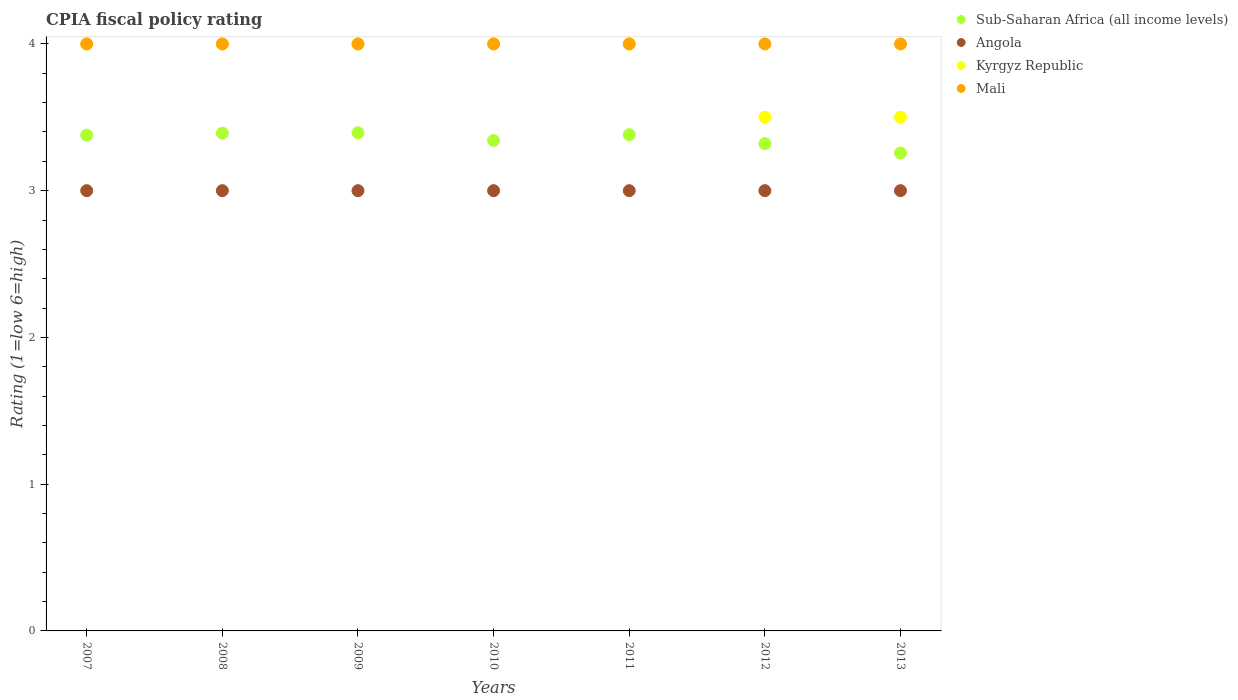Is the number of dotlines equal to the number of legend labels?
Offer a very short reply. Yes. What is the CPIA rating in Kyrgyz Republic in 2010?
Make the answer very short. 4. In which year was the CPIA rating in Kyrgyz Republic minimum?
Your answer should be compact. 2012. What is the total CPIA rating in Sub-Saharan Africa (all income levels) in the graph?
Make the answer very short. 23.47. What is the difference between the CPIA rating in Mali in 2012 and the CPIA rating in Sub-Saharan Africa (all income levels) in 2007?
Offer a terse response. 0.62. What is the average CPIA rating in Kyrgyz Republic per year?
Offer a very short reply. 3.86. In the year 2009, what is the difference between the CPIA rating in Sub-Saharan Africa (all income levels) and CPIA rating in Angola?
Keep it short and to the point. 0.39. Is the difference between the CPIA rating in Sub-Saharan Africa (all income levels) in 2007 and 2012 greater than the difference between the CPIA rating in Angola in 2007 and 2012?
Offer a terse response. Yes. What is the difference between the highest and the second highest CPIA rating in Sub-Saharan Africa (all income levels)?
Keep it short and to the point. 0. What is the difference between the highest and the lowest CPIA rating in Kyrgyz Republic?
Provide a short and direct response. 0.5. Is the sum of the CPIA rating in Kyrgyz Republic in 2008 and 2012 greater than the maximum CPIA rating in Mali across all years?
Provide a short and direct response. Yes. Is it the case that in every year, the sum of the CPIA rating in Angola and CPIA rating in Kyrgyz Republic  is greater than the CPIA rating in Sub-Saharan Africa (all income levels)?
Offer a terse response. Yes. Is the CPIA rating in Kyrgyz Republic strictly greater than the CPIA rating in Mali over the years?
Provide a short and direct response. No. How many years are there in the graph?
Make the answer very short. 7. What is the difference between two consecutive major ticks on the Y-axis?
Ensure brevity in your answer.  1. Are the values on the major ticks of Y-axis written in scientific E-notation?
Your answer should be compact. No. Does the graph contain grids?
Your response must be concise. No. Where does the legend appear in the graph?
Offer a terse response. Top right. How are the legend labels stacked?
Offer a very short reply. Vertical. What is the title of the graph?
Make the answer very short. CPIA fiscal policy rating. Does "Botswana" appear as one of the legend labels in the graph?
Keep it short and to the point. No. What is the Rating (1=low 6=high) in Sub-Saharan Africa (all income levels) in 2007?
Provide a short and direct response. 3.38. What is the Rating (1=low 6=high) in Sub-Saharan Africa (all income levels) in 2008?
Give a very brief answer. 3.39. What is the Rating (1=low 6=high) in Mali in 2008?
Make the answer very short. 4. What is the Rating (1=low 6=high) in Sub-Saharan Africa (all income levels) in 2009?
Ensure brevity in your answer.  3.39. What is the Rating (1=low 6=high) in Angola in 2009?
Offer a terse response. 3. What is the Rating (1=low 6=high) in Mali in 2009?
Your answer should be compact. 4. What is the Rating (1=low 6=high) of Sub-Saharan Africa (all income levels) in 2010?
Your answer should be compact. 3.34. What is the Rating (1=low 6=high) in Angola in 2010?
Offer a very short reply. 3. What is the Rating (1=low 6=high) of Kyrgyz Republic in 2010?
Offer a very short reply. 4. What is the Rating (1=low 6=high) of Sub-Saharan Africa (all income levels) in 2011?
Your answer should be compact. 3.38. What is the Rating (1=low 6=high) in Mali in 2011?
Your answer should be compact. 4. What is the Rating (1=low 6=high) of Sub-Saharan Africa (all income levels) in 2012?
Offer a very short reply. 3.32. What is the Rating (1=low 6=high) in Sub-Saharan Africa (all income levels) in 2013?
Your answer should be very brief. 3.26. What is the Rating (1=low 6=high) of Angola in 2013?
Your response must be concise. 3. What is the Rating (1=low 6=high) in Kyrgyz Republic in 2013?
Provide a succinct answer. 3.5. What is the Rating (1=low 6=high) of Mali in 2013?
Keep it short and to the point. 4. Across all years, what is the maximum Rating (1=low 6=high) of Sub-Saharan Africa (all income levels)?
Your answer should be compact. 3.39. Across all years, what is the maximum Rating (1=low 6=high) of Angola?
Provide a short and direct response. 3. Across all years, what is the maximum Rating (1=low 6=high) of Mali?
Keep it short and to the point. 4. Across all years, what is the minimum Rating (1=low 6=high) in Sub-Saharan Africa (all income levels)?
Provide a short and direct response. 3.26. Across all years, what is the minimum Rating (1=low 6=high) of Angola?
Keep it short and to the point. 3. Across all years, what is the minimum Rating (1=low 6=high) in Kyrgyz Republic?
Your answer should be compact. 3.5. What is the total Rating (1=low 6=high) of Sub-Saharan Africa (all income levels) in the graph?
Ensure brevity in your answer.  23.47. What is the difference between the Rating (1=low 6=high) of Sub-Saharan Africa (all income levels) in 2007 and that in 2008?
Your answer should be very brief. -0.01. What is the difference between the Rating (1=low 6=high) in Angola in 2007 and that in 2008?
Your answer should be compact. 0. What is the difference between the Rating (1=low 6=high) in Sub-Saharan Africa (all income levels) in 2007 and that in 2009?
Your answer should be very brief. -0.02. What is the difference between the Rating (1=low 6=high) in Sub-Saharan Africa (all income levels) in 2007 and that in 2010?
Your response must be concise. 0.04. What is the difference between the Rating (1=low 6=high) in Angola in 2007 and that in 2010?
Provide a short and direct response. 0. What is the difference between the Rating (1=low 6=high) of Mali in 2007 and that in 2010?
Ensure brevity in your answer.  0. What is the difference between the Rating (1=low 6=high) of Sub-Saharan Africa (all income levels) in 2007 and that in 2011?
Provide a succinct answer. -0. What is the difference between the Rating (1=low 6=high) in Angola in 2007 and that in 2011?
Provide a succinct answer. 0. What is the difference between the Rating (1=low 6=high) in Kyrgyz Republic in 2007 and that in 2011?
Offer a very short reply. 0. What is the difference between the Rating (1=low 6=high) in Sub-Saharan Africa (all income levels) in 2007 and that in 2012?
Your answer should be compact. 0.06. What is the difference between the Rating (1=low 6=high) in Angola in 2007 and that in 2012?
Ensure brevity in your answer.  0. What is the difference between the Rating (1=low 6=high) in Mali in 2007 and that in 2012?
Offer a terse response. 0. What is the difference between the Rating (1=low 6=high) in Sub-Saharan Africa (all income levels) in 2007 and that in 2013?
Provide a short and direct response. 0.12. What is the difference between the Rating (1=low 6=high) of Kyrgyz Republic in 2007 and that in 2013?
Make the answer very short. 0.5. What is the difference between the Rating (1=low 6=high) of Sub-Saharan Africa (all income levels) in 2008 and that in 2009?
Offer a very short reply. -0. What is the difference between the Rating (1=low 6=high) in Sub-Saharan Africa (all income levels) in 2008 and that in 2010?
Provide a succinct answer. 0.05. What is the difference between the Rating (1=low 6=high) in Mali in 2008 and that in 2010?
Offer a terse response. 0. What is the difference between the Rating (1=low 6=high) in Sub-Saharan Africa (all income levels) in 2008 and that in 2011?
Provide a short and direct response. 0.01. What is the difference between the Rating (1=low 6=high) of Angola in 2008 and that in 2011?
Offer a very short reply. 0. What is the difference between the Rating (1=low 6=high) in Kyrgyz Republic in 2008 and that in 2011?
Provide a succinct answer. 0. What is the difference between the Rating (1=low 6=high) in Sub-Saharan Africa (all income levels) in 2008 and that in 2012?
Make the answer very short. 0.07. What is the difference between the Rating (1=low 6=high) in Angola in 2008 and that in 2012?
Offer a very short reply. 0. What is the difference between the Rating (1=low 6=high) in Sub-Saharan Africa (all income levels) in 2008 and that in 2013?
Your answer should be compact. 0.14. What is the difference between the Rating (1=low 6=high) of Angola in 2008 and that in 2013?
Make the answer very short. 0. What is the difference between the Rating (1=low 6=high) in Kyrgyz Republic in 2008 and that in 2013?
Offer a very short reply. 0.5. What is the difference between the Rating (1=low 6=high) in Sub-Saharan Africa (all income levels) in 2009 and that in 2010?
Give a very brief answer. 0.05. What is the difference between the Rating (1=low 6=high) of Sub-Saharan Africa (all income levels) in 2009 and that in 2011?
Make the answer very short. 0.01. What is the difference between the Rating (1=low 6=high) of Angola in 2009 and that in 2011?
Offer a very short reply. 0. What is the difference between the Rating (1=low 6=high) of Sub-Saharan Africa (all income levels) in 2009 and that in 2012?
Ensure brevity in your answer.  0.07. What is the difference between the Rating (1=low 6=high) in Angola in 2009 and that in 2012?
Your answer should be very brief. 0. What is the difference between the Rating (1=low 6=high) of Sub-Saharan Africa (all income levels) in 2009 and that in 2013?
Make the answer very short. 0.14. What is the difference between the Rating (1=low 6=high) of Angola in 2009 and that in 2013?
Offer a terse response. 0. What is the difference between the Rating (1=low 6=high) in Mali in 2009 and that in 2013?
Offer a terse response. 0. What is the difference between the Rating (1=low 6=high) of Sub-Saharan Africa (all income levels) in 2010 and that in 2011?
Keep it short and to the point. -0.04. What is the difference between the Rating (1=low 6=high) of Sub-Saharan Africa (all income levels) in 2010 and that in 2012?
Ensure brevity in your answer.  0.02. What is the difference between the Rating (1=low 6=high) in Angola in 2010 and that in 2012?
Your response must be concise. 0. What is the difference between the Rating (1=low 6=high) in Mali in 2010 and that in 2012?
Your answer should be very brief. 0. What is the difference between the Rating (1=low 6=high) in Sub-Saharan Africa (all income levels) in 2010 and that in 2013?
Your answer should be compact. 0.09. What is the difference between the Rating (1=low 6=high) of Kyrgyz Republic in 2010 and that in 2013?
Give a very brief answer. 0.5. What is the difference between the Rating (1=low 6=high) in Sub-Saharan Africa (all income levels) in 2011 and that in 2012?
Keep it short and to the point. 0.06. What is the difference between the Rating (1=low 6=high) of Kyrgyz Republic in 2011 and that in 2012?
Provide a succinct answer. 0.5. What is the difference between the Rating (1=low 6=high) of Mali in 2011 and that in 2012?
Provide a short and direct response. 0. What is the difference between the Rating (1=low 6=high) in Sub-Saharan Africa (all income levels) in 2011 and that in 2013?
Your answer should be very brief. 0.13. What is the difference between the Rating (1=low 6=high) in Sub-Saharan Africa (all income levels) in 2012 and that in 2013?
Offer a terse response. 0.06. What is the difference between the Rating (1=low 6=high) in Angola in 2012 and that in 2013?
Keep it short and to the point. 0. What is the difference between the Rating (1=low 6=high) in Mali in 2012 and that in 2013?
Offer a very short reply. 0. What is the difference between the Rating (1=low 6=high) in Sub-Saharan Africa (all income levels) in 2007 and the Rating (1=low 6=high) in Angola in 2008?
Your answer should be very brief. 0.38. What is the difference between the Rating (1=low 6=high) of Sub-Saharan Africa (all income levels) in 2007 and the Rating (1=low 6=high) of Kyrgyz Republic in 2008?
Ensure brevity in your answer.  -0.62. What is the difference between the Rating (1=low 6=high) in Sub-Saharan Africa (all income levels) in 2007 and the Rating (1=low 6=high) in Mali in 2008?
Your response must be concise. -0.62. What is the difference between the Rating (1=low 6=high) in Sub-Saharan Africa (all income levels) in 2007 and the Rating (1=low 6=high) in Angola in 2009?
Keep it short and to the point. 0.38. What is the difference between the Rating (1=low 6=high) of Sub-Saharan Africa (all income levels) in 2007 and the Rating (1=low 6=high) of Kyrgyz Republic in 2009?
Your response must be concise. -0.62. What is the difference between the Rating (1=low 6=high) in Sub-Saharan Africa (all income levels) in 2007 and the Rating (1=low 6=high) in Mali in 2009?
Provide a succinct answer. -0.62. What is the difference between the Rating (1=low 6=high) of Angola in 2007 and the Rating (1=low 6=high) of Kyrgyz Republic in 2009?
Offer a very short reply. -1. What is the difference between the Rating (1=low 6=high) in Angola in 2007 and the Rating (1=low 6=high) in Mali in 2009?
Provide a short and direct response. -1. What is the difference between the Rating (1=low 6=high) of Kyrgyz Republic in 2007 and the Rating (1=low 6=high) of Mali in 2009?
Provide a short and direct response. 0. What is the difference between the Rating (1=low 6=high) in Sub-Saharan Africa (all income levels) in 2007 and the Rating (1=low 6=high) in Angola in 2010?
Make the answer very short. 0.38. What is the difference between the Rating (1=low 6=high) of Sub-Saharan Africa (all income levels) in 2007 and the Rating (1=low 6=high) of Kyrgyz Republic in 2010?
Offer a terse response. -0.62. What is the difference between the Rating (1=low 6=high) of Sub-Saharan Africa (all income levels) in 2007 and the Rating (1=low 6=high) of Mali in 2010?
Your answer should be very brief. -0.62. What is the difference between the Rating (1=low 6=high) of Angola in 2007 and the Rating (1=low 6=high) of Mali in 2010?
Ensure brevity in your answer.  -1. What is the difference between the Rating (1=low 6=high) in Sub-Saharan Africa (all income levels) in 2007 and the Rating (1=low 6=high) in Angola in 2011?
Offer a terse response. 0.38. What is the difference between the Rating (1=low 6=high) of Sub-Saharan Africa (all income levels) in 2007 and the Rating (1=low 6=high) of Kyrgyz Republic in 2011?
Give a very brief answer. -0.62. What is the difference between the Rating (1=low 6=high) in Sub-Saharan Africa (all income levels) in 2007 and the Rating (1=low 6=high) in Mali in 2011?
Provide a succinct answer. -0.62. What is the difference between the Rating (1=low 6=high) in Sub-Saharan Africa (all income levels) in 2007 and the Rating (1=low 6=high) in Angola in 2012?
Ensure brevity in your answer.  0.38. What is the difference between the Rating (1=low 6=high) in Sub-Saharan Africa (all income levels) in 2007 and the Rating (1=low 6=high) in Kyrgyz Republic in 2012?
Ensure brevity in your answer.  -0.12. What is the difference between the Rating (1=low 6=high) in Sub-Saharan Africa (all income levels) in 2007 and the Rating (1=low 6=high) in Mali in 2012?
Make the answer very short. -0.62. What is the difference between the Rating (1=low 6=high) in Angola in 2007 and the Rating (1=low 6=high) in Mali in 2012?
Provide a succinct answer. -1. What is the difference between the Rating (1=low 6=high) of Kyrgyz Republic in 2007 and the Rating (1=low 6=high) of Mali in 2012?
Ensure brevity in your answer.  0. What is the difference between the Rating (1=low 6=high) of Sub-Saharan Africa (all income levels) in 2007 and the Rating (1=low 6=high) of Angola in 2013?
Your answer should be very brief. 0.38. What is the difference between the Rating (1=low 6=high) in Sub-Saharan Africa (all income levels) in 2007 and the Rating (1=low 6=high) in Kyrgyz Republic in 2013?
Offer a very short reply. -0.12. What is the difference between the Rating (1=low 6=high) of Sub-Saharan Africa (all income levels) in 2007 and the Rating (1=low 6=high) of Mali in 2013?
Give a very brief answer. -0.62. What is the difference between the Rating (1=low 6=high) in Angola in 2007 and the Rating (1=low 6=high) in Kyrgyz Republic in 2013?
Your answer should be very brief. -0.5. What is the difference between the Rating (1=low 6=high) in Sub-Saharan Africa (all income levels) in 2008 and the Rating (1=low 6=high) in Angola in 2009?
Provide a short and direct response. 0.39. What is the difference between the Rating (1=low 6=high) in Sub-Saharan Africa (all income levels) in 2008 and the Rating (1=low 6=high) in Kyrgyz Republic in 2009?
Your answer should be compact. -0.61. What is the difference between the Rating (1=low 6=high) in Sub-Saharan Africa (all income levels) in 2008 and the Rating (1=low 6=high) in Mali in 2009?
Give a very brief answer. -0.61. What is the difference between the Rating (1=low 6=high) of Angola in 2008 and the Rating (1=low 6=high) of Kyrgyz Republic in 2009?
Your answer should be very brief. -1. What is the difference between the Rating (1=low 6=high) of Angola in 2008 and the Rating (1=low 6=high) of Mali in 2009?
Provide a succinct answer. -1. What is the difference between the Rating (1=low 6=high) in Kyrgyz Republic in 2008 and the Rating (1=low 6=high) in Mali in 2009?
Ensure brevity in your answer.  0. What is the difference between the Rating (1=low 6=high) in Sub-Saharan Africa (all income levels) in 2008 and the Rating (1=low 6=high) in Angola in 2010?
Your response must be concise. 0.39. What is the difference between the Rating (1=low 6=high) of Sub-Saharan Africa (all income levels) in 2008 and the Rating (1=low 6=high) of Kyrgyz Republic in 2010?
Ensure brevity in your answer.  -0.61. What is the difference between the Rating (1=low 6=high) of Sub-Saharan Africa (all income levels) in 2008 and the Rating (1=low 6=high) of Mali in 2010?
Your answer should be very brief. -0.61. What is the difference between the Rating (1=low 6=high) of Angola in 2008 and the Rating (1=low 6=high) of Kyrgyz Republic in 2010?
Give a very brief answer. -1. What is the difference between the Rating (1=low 6=high) of Angola in 2008 and the Rating (1=low 6=high) of Mali in 2010?
Make the answer very short. -1. What is the difference between the Rating (1=low 6=high) of Kyrgyz Republic in 2008 and the Rating (1=low 6=high) of Mali in 2010?
Keep it short and to the point. 0. What is the difference between the Rating (1=low 6=high) of Sub-Saharan Africa (all income levels) in 2008 and the Rating (1=low 6=high) of Angola in 2011?
Keep it short and to the point. 0.39. What is the difference between the Rating (1=low 6=high) of Sub-Saharan Africa (all income levels) in 2008 and the Rating (1=low 6=high) of Kyrgyz Republic in 2011?
Give a very brief answer. -0.61. What is the difference between the Rating (1=low 6=high) in Sub-Saharan Africa (all income levels) in 2008 and the Rating (1=low 6=high) in Mali in 2011?
Make the answer very short. -0.61. What is the difference between the Rating (1=low 6=high) in Angola in 2008 and the Rating (1=low 6=high) in Kyrgyz Republic in 2011?
Make the answer very short. -1. What is the difference between the Rating (1=low 6=high) in Angola in 2008 and the Rating (1=low 6=high) in Mali in 2011?
Offer a terse response. -1. What is the difference between the Rating (1=low 6=high) of Kyrgyz Republic in 2008 and the Rating (1=low 6=high) of Mali in 2011?
Provide a short and direct response. 0. What is the difference between the Rating (1=low 6=high) of Sub-Saharan Africa (all income levels) in 2008 and the Rating (1=low 6=high) of Angola in 2012?
Your answer should be very brief. 0.39. What is the difference between the Rating (1=low 6=high) in Sub-Saharan Africa (all income levels) in 2008 and the Rating (1=low 6=high) in Kyrgyz Republic in 2012?
Give a very brief answer. -0.11. What is the difference between the Rating (1=low 6=high) of Sub-Saharan Africa (all income levels) in 2008 and the Rating (1=low 6=high) of Mali in 2012?
Offer a terse response. -0.61. What is the difference between the Rating (1=low 6=high) in Angola in 2008 and the Rating (1=low 6=high) in Mali in 2012?
Provide a short and direct response. -1. What is the difference between the Rating (1=low 6=high) in Kyrgyz Republic in 2008 and the Rating (1=low 6=high) in Mali in 2012?
Keep it short and to the point. 0. What is the difference between the Rating (1=low 6=high) of Sub-Saharan Africa (all income levels) in 2008 and the Rating (1=low 6=high) of Angola in 2013?
Provide a short and direct response. 0.39. What is the difference between the Rating (1=low 6=high) in Sub-Saharan Africa (all income levels) in 2008 and the Rating (1=low 6=high) in Kyrgyz Republic in 2013?
Provide a short and direct response. -0.11. What is the difference between the Rating (1=low 6=high) in Sub-Saharan Africa (all income levels) in 2008 and the Rating (1=low 6=high) in Mali in 2013?
Provide a short and direct response. -0.61. What is the difference between the Rating (1=low 6=high) in Angola in 2008 and the Rating (1=low 6=high) in Kyrgyz Republic in 2013?
Provide a short and direct response. -0.5. What is the difference between the Rating (1=low 6=high) in Angola in 2008 and the Rating (1=low 6=high) in Mali in 2013?
Offer a very short reply. -1. What is the difference between the Rating (1=low 6=high) of Kyrgyz Republic in 2008 and the Rating (1=low 6=high) of Mali in 2013?
Provide a succinct answer. 0. What is the difference between the Rating (1=low 6=high) in Sub-Saharan Africa (all income levels) in 2009 and the Rating (1=low 6=high) in Angola in 2010?
Keep it short and to the point. 0.39. What is the difference between the Rating (1=low 6=high) in Sub-Saharan Africa (all income levels) in 2009 and the Rating (1=low 6=high) in Kyrgyz Republic in 2010?
Give a very brief answer. -0.61. What is the difference between the Rating (1=low 6=high) in Sub-Saharan Africa (all income levels) in 2009 and the Rating (1=low 6=high) in Mali in 2010?
Ensure brevity in your answer.  -0.61. What is the difference between the Rating (1=low 6=high) in Angola in 2009 and the Rating (1=low 6=high) in Kyrgyz Republic in 2010?
Provide a succinct answer. -1. What is the difference between the Rating (1=low 6=high) of Angola in 2009 and the Rating (1=low 6=high) of Mali in 2010?
Your answer should be compact. -1. What is the difference between the Rating (1=low 6=high) of Sub-Saharan Africa (all income levels) in 2009 and the Rating (1=low 6=high) of Angola in 2011?
Keep it short and to the point. 0.39. What is the difference between the Rating (1=low 6=high) of Sub-Saharan Africa (all income levels) in 2009 and the Rating (1=low 6=high) of Kyrgyz Republic in 2011?
Offer a very short reply. -0.61. What is the difference between the Rating (1=low 6=high) of Sub-Saharan Africa (all income levels) in 2009 and the Rating (1=low 6=high) of Mali in 2011?
Make the answer very short. -0.61. What is the difference between the Rating (1=low 6=high) of Angola in 2009 and the Rating (1=low 6=high) of Kyrgyz Republic in 2011?
Your answer should be compact. -1. What is the difference between the Rating (1=low 6=high) in Angola in 2009 and the Rating (1=low 6=high) in Mali in 2011?
Make the answer very short. -1. What is the difference between the Rating (1=low 6=high) of Kyrgyz Republic in 2009 and the Rating (1=low 6=high) of Mali in 2011?
Your answer should be compact. 0. What is the difference between the Rating (1=low 6=high) of Sub-Saharan Africa (all income levels) in 2009 and the Rating (1=low 6=high) of Angola in 2012?
Offer a terse response. 0.39. What is the difference between the Rating (1=low 6=high) in Sub-Saharan Africa (all income levels) in 2009 and the Rating (1=low 6=high) in Kyrgyz Republic in 2012?
Keep it short and to the point. -0.11. What is the difference between the Rating (1=low 6=high) in Sub-Saharan Africa (all income levels) in 2009 and the Rating (1=low 6=high) in Mali in 2012?
Provide a succinct answer. -0.61. What is the difference between the Rating (1=low 6=high) in Sub-Saharan Africa (all income levels) in 2009 and the Rating (1=low 6=high) in Angola in 2013?
Provide a short and direct response. 0.39. What is the difference between the Rating (1=low 6=high) of Sub-Saharan Africa (all income levels) in 2009 and the Rating (1=low 6=high) of Kyrgyz Republic in 2013?
Offer a terse response. -0.11. What is the difference between the Rating (1=low 6=high) of Sub-Saharan Africa (all income levels) in 2009 and the Rating (1=low 6=high) of Mali in 2013?
Your response must be concise. -0.61. What is the difference between the Rating (1=low 6=high) of Angola in 2009 and the Rating (1=low 6=high) of Kyrgyz Republic in 2013?
Keep it short and to the point. -0.5. What is the difference between the Rating (1=low 6=high) in Sub-Saharan Africa (all income levels) in 2010 and the Rating (1=low 6=high) in Angola in 2011?
Your answer should be compact. 0.34. What is the difference between the Rating (1=low 6=high) of Sub-Saharan Africa (all income levels) in 2010 and the Rating (1=low 6=high) of Kyrgyz Republic in 2011?
Give a very brief answer. -0.66. What is the difference between the Rating (1=low 6=high) of Sub-Saharan Africa (all income levels) in 2010 and the Rating (1=low 6=high) of Mali in 2011?
Offer a very short reply. -0.66. What is the difference between the Rating (1=low 6=high) of Angola in 2010 and the Rating (1=low 6=high) of Kyrgyz Republic in 2011?
Offer a very short reply. -1. What is the difference between the Rating (1=low 6=high) in Sub-Saharan Africa (all income levels) in 2010 and the Rating (1=low 6=high) in Angola in 2012?
Your answer should be compact. 0.34. What is the difference between the Rating (1=low 6=high) of Sub-Saharan Africa (all income levels) in 2010 and the Rating (1=low 6=high) of Kyrgyz Republic in 2012?
Provide a succinct answer. -0.16. What is the difference between the Rating (1=low 6=high) of Sub-Saharan Africa (all income levels) in 2010 and the Rating (1=low 6=high) of Mali in 2012?
Offer a very short reply. -0.66. What is the difference between the Rating (1=low 6=high) of Angola in 2010 and the Rating (1=low 6=high) of Mali in 2012?
Offer a terse response. -1. What is the difference between the Rating (1=low 6=high) in Kyrgyz Republic in 2010 and the Rating (1=low 6=high) in Mali in 2012?
Ensure brevity in your answer.  0. What is the difference between the Rating (1=low 6=high) in Sub-Saharan Africa (all income levels) in 2010 and the Rating (1=low 6=high) in Angola in 2013?
Keep it short and to the point. 0.34. What is the difference between the Rating (1=low 6=high) in Sub-Saharan Africa (all income levels) in 2010 and the Rating (1=low 6=high) in Kyrgyz Republic in 2013?
Your response must be concise. -0.16. What is the difference between the Rating (1=low 6=high) in Sub-Saharan Africa (all income levels) in 2010 and the Rating (1=low 6=high) in Mali in 2013?
Provide a succinct answer. -0.66. What is the difference between the Rating (1=low 6=high) of Sub-Saharan Africa (all income levels) in 2011 and the Rating (1=low 6=high) of Angola in 2012?
Provide a short and direct response. 0.38. What is the difference between the Rating (1=low 6=high) of Sub-Saharan Africa (all income levels) in 2011 and the Rating (1=low 6=high) of Kyrgyz Republic in 2012?
Give a very brief answer. -0.12. What is the difference between the Rating (1=low 6=high) of Sub-Saharan Africa (all income levels) in 2011 and the Rating (1=low 6=high) of Mali in 2012?
Make the answer very short. -0.62. What is the difference between the Rating (1=low 6=high) of Kyrgyz Republic in 2011 and the Rating (1=low 6=high) of Mali in 2012?
Provide a succinct answer. 0. What is the difference between the Rating (1=low 6=high) of Sub-Saharan Africa (all income levels) in 2011 and the Rating (1=low 6=high) of Angola in 2013?
Ensure brevity in your answer.  0.38. What is the difference between the Rating (1=low 6=high) in Sub-Saharan Africa (all income levels) in 2011 and the Rating (1=low 6=high) in Kyrgyz Republic in 2013?
Offer a very short reply. -0.12. What is the difference between the Rating (1=low 6=high) of Sub-Saharan Africa (all income levels) in 2011 and the Rating (1=low 6=high) of Mali in 2013?
Offer a terse response. -0.62. What is the difference between the Rating (1=low 6=high) in Angola in 2011 and the Rating (1=low 6=high) in Mali in 2013?
Ensure brevity in your answer.  -1. What is the difference between the Rating (1=low 6=high) of Kyrgyz Republic in 2011 and the Rating (1=low 6=high) of Mali in 2013?
Provide a short and direct response. 0. What is the difference between the Rating (1=low 6=high) of Sub-Saharan Africa (all income levels) in 2012 and the Rating (1=low 6=high) of Angola in 2013?
Keep it short and to the point. 0.32. What is the difference between the Rating (1=low 6=high) in Sub-Saharan Africa (all income levels) in 2012 and the Rating (1=low 6=high) in Kyrgyz Republic in 2013?
Your answer should be very brief. -0.18. What is the difference between the Rating (1=low 6=high) in Sub-Saharan Africa (all income levels) in 2012 and the Rating (1=low 6=high) in Mali in 2013?
Ensure brevity in your answer.  -0.68. What is the difference between the Rating (1=low 6=high) in Angola in 2012 and the Rating (1=low 6=high) in Kyrgyz Republic in 2013?
Your answer should be compact. -0.5. What is the difference between the Rating (1=low 6=high) of Kyrgyz Republic in 2012 and the Rating (1=low 6=high) of Mali in 2013?
Provide a succinct answer. -0.5. What is the average Rating (1=low 6=high) of Sub-Saharan Africa (all income levels) per year?
Provide a short and direct response. 3.35. What is the average Rating (1=low 6=high) in Angola per year?
Offer a very short reply. 3. What is the average Rating (1=low 6=high) in Kyrgyz Republic per year?
Keep it short and to the point. 3.86. In the year 2007, what is the difference between the Rating (1=low 6=high) of Sub-Saharan Africa (all income levels) and Rating (1=low 6=high) of Angola?
Give a very brief answer. 0.38. In the year 2007, what is the difference between the Rating (1=low 6=high) of Sub-Saharan Africa (all income levels) and Rating (1=low 6=high) of Kyrgyz Republic?
Ensure brevity in your answer.  -0.62. In the year 2007, what is the difference between the Rating (1=low 6=high) in Sub-Saharan Africa (all income levels) and Rating (1=low 6=high) in Mali?
Your answer should be very brief. -0.62. In the year 2007, what is the difference between the Rating (1=low 6=high) in Angola and Rating (1=low 6=high) in Kyrgyz Republic?
Make the answer very short. -1. In the year 2008, what is the difference between the Rating (1=low 6=high) of Sub-Saharan Africa (all income levels) and Rating (1=low 6=high) of Angola?
Provide a short and direct response. 0.39. In the year 2008, what is the difference between the Rating (1=low 6=high) of Sub-Saharan Africa (all income levels) and Rating (1=low 6=high) of Kyrgyz Republic?
Give a very brief answer. -0.61. In the year 2008, what is the difference between the Rating (1=low 6=high) of Sub-Saharan Africa (all income levels) and Rating (1=low 6=high) of Mali?
Your response must be concise. -0.61. In the year 2008, what is the difference between the Rating (1=low 6=high) in Angola and Rating (1=low 6=high) in Mali?
Offer a terse response. -1. In the year 2009, what is the difference between the Rating (1=low 6=high) in Sub-Saharan Africa (all income levels) and Rating (1=low 6=high) in Angola?
Offer a terse response. 0.39. In the year 2009, what is the difference between the Rating (1=low 6=high) in Sub-Saharan Africa (all income levels) and Rating (1=low 6=high) in Kyrgyz Republic?
Provide a succinct answer. -0.61. In the year 2009, what is the difference between the Rating (1=low 6=high) of Sub-Saharan Africa (all income levels) and Rating (1=low 6=high) of Mali?
Offer a very short reply. -0.61. In the year 2009, what is the difference between the Rating (1=low 6=high) in Angola and Rating (1=low 6=high) in Kyrgyz Republic?
Your answer should be compact. -1. In the year 2009, what is the difference between the Rating (1=low 6=high) of Angola and Rating (1=low 6=high) of Mali?
Offer a terse response. -1. In the year 2010, what is the difference between the Rating (1=low 6=high) in Sub-Saharan Africa (all income levels) and Rating (1=low 6=high) in Angola?
Offer a very short reply. 0.34. In the year 2010, what is the difference between the Rating (1=low 6=high) of Sub-Saharan Africa (all income levels) and Rating (1=low 6=high) of Kyrgyz Republic?
Offer a terse response. -0.66. In the year 2010, what is the difference between the Rating (1=low 6=high) in Sub-Saharan Africa (all income levels) and Rating (1=low 6=high) in Mali?
Give a very brief answer. -0.66. In the year 2010, what is the difference between the Rating (1=low 6=high) in Angola and Rating (1=low 6=high) in Kyrgyz Republic?
Give a very brief answer. -1. In the year 2010, what is the difference between the Rating (1=low 6=high) in Angola and Rating (1=low 6=high) in Mali?
Your answer should be very brief. -1. In the year 2010, what is the difference between the Rating (1=low 6=high) in Kyrgyz Republic and Rating (1=low 6=high) in Mali?
Offer a terse response. 0. In the year 2011, what is the difference between the Rating (1=low 6=high) in Sub-Saharan Africa (all income levels) and Rating (1=low 6=high) in Angola?
Offer a terse response. 0.38. In the year 2011, what is the difference between the Rating (1=low 6=high) of Sub-Saharan Africa (all income levels) and Rating (1=low 6=high) of Kyrgyz Republic?
Your answer should be compact. -0.62. In the year 2011, what is the difference between the Rating (1=low 6=high) in Sub-Saharan Africa (all income levels) and Rating (1=low 6=high) in Mali?
Offer a terse response. -0.62. In the year 2011, what is the difference between the Rating (1=low 6=high) of Angola and Rating (1=low 6=high) of Kyrgyz Republic?
Your answer should be very brief. -1. In the year 2011, what is the difference between the Rating (1=low 6=high) in Angola and Rating (1=low 6=high) in Mali?
Keep it short and to the point. -1. In the year 2012, what is the difference between the Rating (1=low 6=high) in Sub-Saharan Africa (all income levels) and Rating (1=low 6=high) in Angola?
Offer a very short reply. 0.32. In the year 2012, what is the difference between the Rating (1=low 6=high) in Sub-Saharan Africa (all income levels) and Rating (1=low 6=high) in Kyrgyz Republic?
Your response must be concise. -0.18. In the year 2012, what is the difference between the Rating (1=low 6=high) in Sub-Saharan Africa (all income levels) and Rating (1=low 6=high) in Mali?
Your answer should be very brief. -0.68. In the year 2013, what is the difference between the Rating (1=low 6=high) in Sub-Saharan Africa (all income levels) and Rating (1=low 6=high) in Angola?
Provide a short and direct response. 0.26. In the year 2013, what is the difference between the Rating (1=low 6=high) in Sub-Saharan Africa (all income levels) and Rating (1=low 6=high) in Kyrgyz Republic?
Your answer should be compact. -0.24. In the year 2013, what is the difference between the Rating (1=low 6=high) in Sub-Saharan Africa (all income levels) and Rating (1=low 6=high) in Mali?
Your response must be concise. -0.74. In the year 2013, what is the difference between the Rating (1=low 6=high) of Angola and Rating (1=low 6=high) of Mali?
Your response must be concise. -1. In the year 2013, what is the difference between the Rating (1=low 6=high) of Kyrgyz Republic and Rating (1=low 6=high) of Mali?
Offer a very short reply. -0.5. What is the ratio of the Rating (1=low 6=high) of Angola in 2007 to that in 2008?
Provide a succinct answer. 1. What is the ratio of the Rating (1=low 6=high) of Kyrgyz Republic in 2007 to that in 2008?
Give a very brief answer. 1. What is the ratio of the Rating (1=low 6=high) in Sub-Saharan Africa (all income levels) in 2007 to that in 2009?
Offer a very short reply. 1. What is the ratio of the Rating (1=low 6=high) in Sub-Saharan Africa (all income levels) in 2007 to that in 2010?
Make the answer very short. 1.01. What is the ratio of the Rating (1=low 6=high) of Mali in 2007 to that in 2010?
Make the answer very short. 1. What is the ratio of the Rating (1=low 6=high) in Sub-Saharan Africa (all income levels) in 2007 to that in 2011?
Your answer should be compact. 1. What is the ratio of the Rating (1=low 6=high) of Kyrgyz Republic in 2007 to that in 2011?
Your response must be concise. 1. What is the ratio of the Rating (1=low 6=high) in Sub-Saharan Africa (all income levels) in 2007 to that in 2012?
Keep it short and to the point. 1.02. What is the ratio of the Rating (1=low 6=high) of Angola in 2007 to that in 2012?
Make the answer very short. 1. What is the ratio of the Rating (1=low 6=high) in Mali in 2007 to that in 2012?
Keep it short and to the point. 1. What is the ratio of the Rating (1=low 6=high) in Sub-Saharan Africa (all income levels) in 2007 to that in 2013?
Offer a very short reply. 1.04. What is the ratio of the Rating (1=low 6=high) of Angola in 2007 to that in 2013?
Provide a succinct answer. 1. What is the ratio of the Rating (1=low 6=high) of Mali in 2007 to that in 2013?
Provide a succinct answer. 1. What is the ratio of the Rating (1=low 6=high) in Sub-Saharan Africa (all income levels) in 2008 to that in 2009?
Your response must be concise. 1. What is the ratio of the Rating (1=low 6=high) in Kyrgyz Republic in 2008 to that in 2009?
Provide a short and direct response. 1. What is the ratio of the Rating (1=low 6=high) in Mali in 2008 to that in 2009?
Your answer should be compact. 1. What is the ratio of the Rating (1=low 6=high) of Sub-Saharan Africa (all income levels) in 2008 to that in 2010?
Offer a very short reply. 1.01. What is the ratio of the Rating (1=low 6=high) of Angola in 2008 to that in 2010?
Provide a short and direct response. 1. What is the ratio of the Rating (1=low 6=high) in Sub-Saharan Africa (all income levels) in 2008 to that in 2012?
Ensure brevity in your answer.  1.02. What is the ratio of the Rating (1=low 6=high) of Kyrgyz Republic in 2008 to that in 2012?
Give a very brief answer. 1.14. What is the ratio of the Rating (1=low 6=high) of Sub-Saharan Africa (all income levels) in 2008 to that in 2013?
Your response must be concise. 1.04. What is the ratio of the Rating (1=low 6=high) in Kyrgyz Republic in 2008 to that in 2013?
Your answer should be compact. 1.14. What is the ratio of the Rating (1=low 6=high) in Sub-Saharan Africa (all income levels) in 2009 to that in 2010?
Provide a short and direct response. 1.02. What is the ratio of the Rating (1=low 6=high) in Angola in 2009 to that in 2010?
Offer a very short reply. 1. What is the ratio of the Rating (1=low 6=high) of Kyrgyz Republic in 2009 to that in 2010?
Offer a terse response. 1. What is the ratio of the Rating (1=low 6=high) of Mali in 2009 to that in 2010?
Keep it short and to the point. 1. What is the ratio of the Rating (1=low 6=high) of Sub-Saharan Africa (all income levels) in 2009 to that in 2011?
Your answer should be very brief. 1. What is the ratio of the Rating (1=low 6=high) in Angola in 2009 to that in 2011?
Your answer should be compact. 1. What is the ratio of the Rating (1=low 6=high) in Mali in 2009 to that in 2011?
Ensure brevity in your answer.  1. What is the ratio of the Rating (1=low 6=high) in Sub-Saharan Africa (all income levels) in 2009 to that in 2012?
Offer a terse response. 1.02. What is the ratio of the Rating (1=low 6=high) of Angola in 2009 to that in 2012?
Your answer should be compact. 1. What is the ratio of the Rating (1=low 6=high) in Sub-Saharan Africa (all income levels) in 2009 to that in 2013?
Provide a succinct answer. 1.04. What is the ratio of the Rating (1=low 6=high) of Kyrgyz Republic in 2009 to that in 2013?
Make the answer very short. 1.14. What is the ratio of the Rating (1=low 6=high) in Mali in 2009 to that in 2013?
Ensure brevity in your answer.  1. What is the ratio of the Rating (1=low 6=high) of Sub-Saharan Africa (all income levels) in 2010 to that in 2011?
Offer a very short reply. 0.99. What is the ratio of the Rating (1=low 6=high) in Angola in 2010 to that in 2011?
Provide a short and direct response. 1. What is the ratio of the Rating (1=low 6=high) in Mali in 2010 to that in 2011?
Your response must be concise. 1. What is the ratio of the Rating (1=low 6=high) of Sub-Saharan Africa (all income levels) in 2010 to that in 2012?
Your answer should be compact. 1.01. What is the ratio of the Rating (1=low 6=high) of Angola in 2010 to that in 2012?
Make the answer very short. 1. What is the ratio of the Rating (1=low 6=high) in Kyrgyz Republic in 2010 to that in 2012?
Make the answer very short. 1.14. What is the ratio of the Rating (1=low 6=high) of Sub-Saharan Africa (all income levels) in 2010 to that in 2013?
Provide a short and direct response. 1.03. What is the ratio of the Rating (1=low 6=high) of Angola in 2010 to that in 2013?
Make the answer very short. 1. What is the ratio of the Rating (1=low 6=high) of Kyrgyz Republic in 2010 to that in 2013?
Offer a very short reply. 1.14. What is the ratio of the Rating (1=low 6=high) in Mali in 2010 to that in 2013?
Offer a terse response. 1. What is the ratio of the Rating (1=low 6=high) in Sub-Saharan Africa (all income levels) in 2011 to that in 2012?
Your answer should be very brief. 1.02. What is the ratio of the Rating (1=low 6=high) of Angola in 2011 to that in 2012?
Give a very brief answer. 1. What is the ratio of the Rating (1=low 6=high) in Kyrgyz Republic in 2011 to that in 2012?
Your answer should be compact. 1.14. What is the ratio of the Rating (1=low 6=high) of Mali in 2011 to that in 2012?
Provide a short and direct response. 1. What is the ratio of the Rating (1=low 6=high) in Sub-Saharan Africa (all income levels) in 2011 to that in 2013?
Offer a terse response. 1.04. What is the ratio of the Rating (1=low 6=high) of Angola in 2011 to that in 2013?
Your response must be concise. 1. What is the ratio of the Rating (1=low 6=high) of Kyrgyz Republic in 2011 to that in 2013?
Make the answer very short. 1.14. What is the ratio of the Rating (1=low 6=high) in Sub-Saharan Africa (all income levels) in 2012 to that in 2013?
Offer a terse response. 1.02. What is the ratio of the Rating (1=low 6=high) of Kyrgyz Republic in 2012 to that in 2013?
Your answer should be very brief. 1. What is the ratio of the Rating (1=low 6=high) of Mali in 2012 to that in 2013?
Give a very brief answer. 1. What is the difference between the highest and the second highest Rating (1=low 6=high) of Sub-Saharan Africa (all income levels)?
Give a very brief answer. 0. What is the difference between the highest and the second highest Rating (1=low 6=high) in Angola?
Your answer should be very brief. 0. What is the difference between the highest and the second highest Rating (1=low 6=high) in Mali?
Ensure brevity in your answer.  0. What is the difference between the highest and the lowest Rating (1=low 6=high) of Sub-Saharan Africa (all income levels)?
Ensure brevity in your answer.  0.14. What is the difference between the highest and the lowest Rating (1=low 6=high) of Kyrgyz Republic?
Offer a terse response. 0.5. 